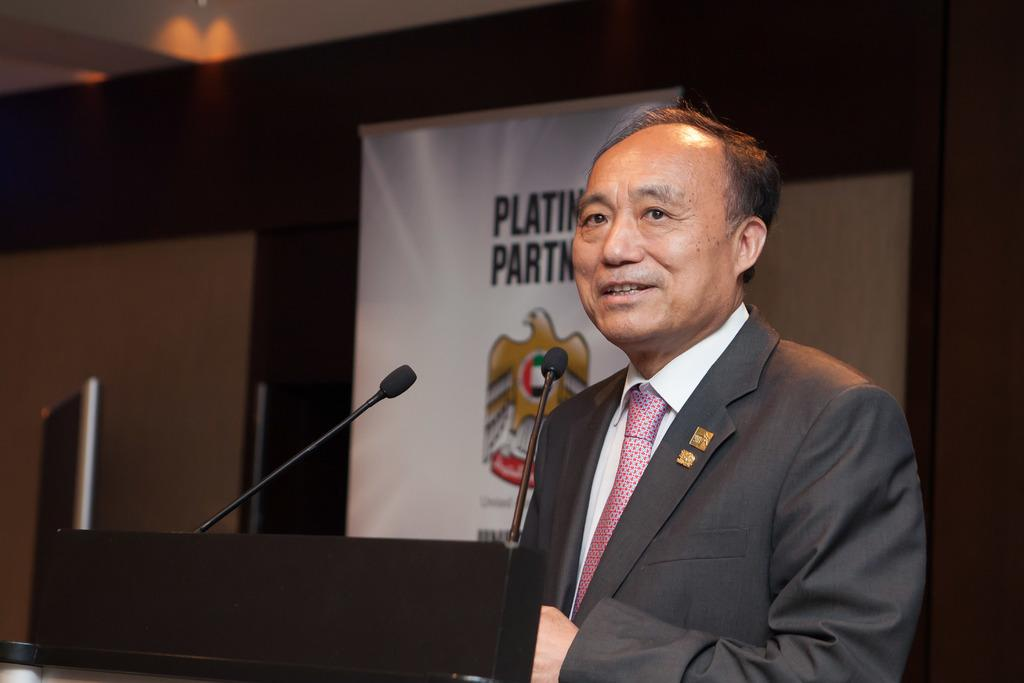What object is present in the image that is used for amplifying sound? There is a mic in the image. Can you describe the person in the image? The person in the image is wearing a blazer. What can be seen in the background of the image? There is a banner in the image. Where is the mother holding the pump in the image? There is no mother or pump present in the image. What is the person using to carry the tray in the image? There is no tray present in the image. 